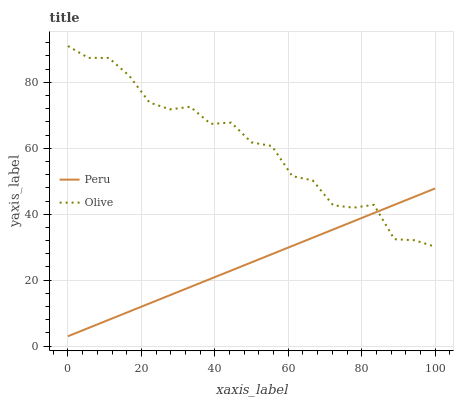Does Peru have the minimum area under the curve?
Answer yes or no. Yes. Does Olive have the maximum area under the curve?
Answer yes or no. Yes. Does Peru have the maximum area under the curve?
Answer yes or no. No. Is Peru the smoothest?
Answer yes or no. Yes. Is Olive the roughest?
Answer yes or no. Yes. Is Peru the roughest?
Answer yes or no. No. Does Olive have the highest value?
Answer yes or no. Yes. Does Peru have the highest value?
Answer yes or no. No. Does Olive intersect Peru?
Answer yes or no. Yes. Is Olive less than Peru?
Answer yes or no. No. Is Olive greater than Peru?
Answer yes or no. No. 